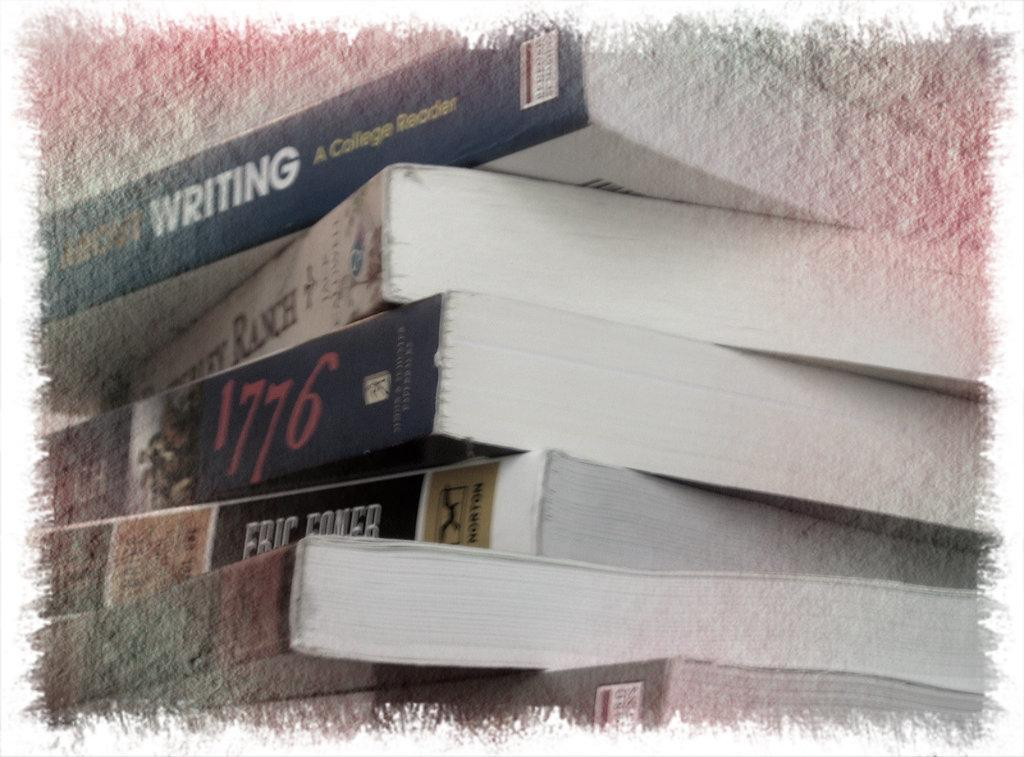<image>
Share a concise interpretation of the image provided. Several books stacked together with one mentioning the year 1776. 